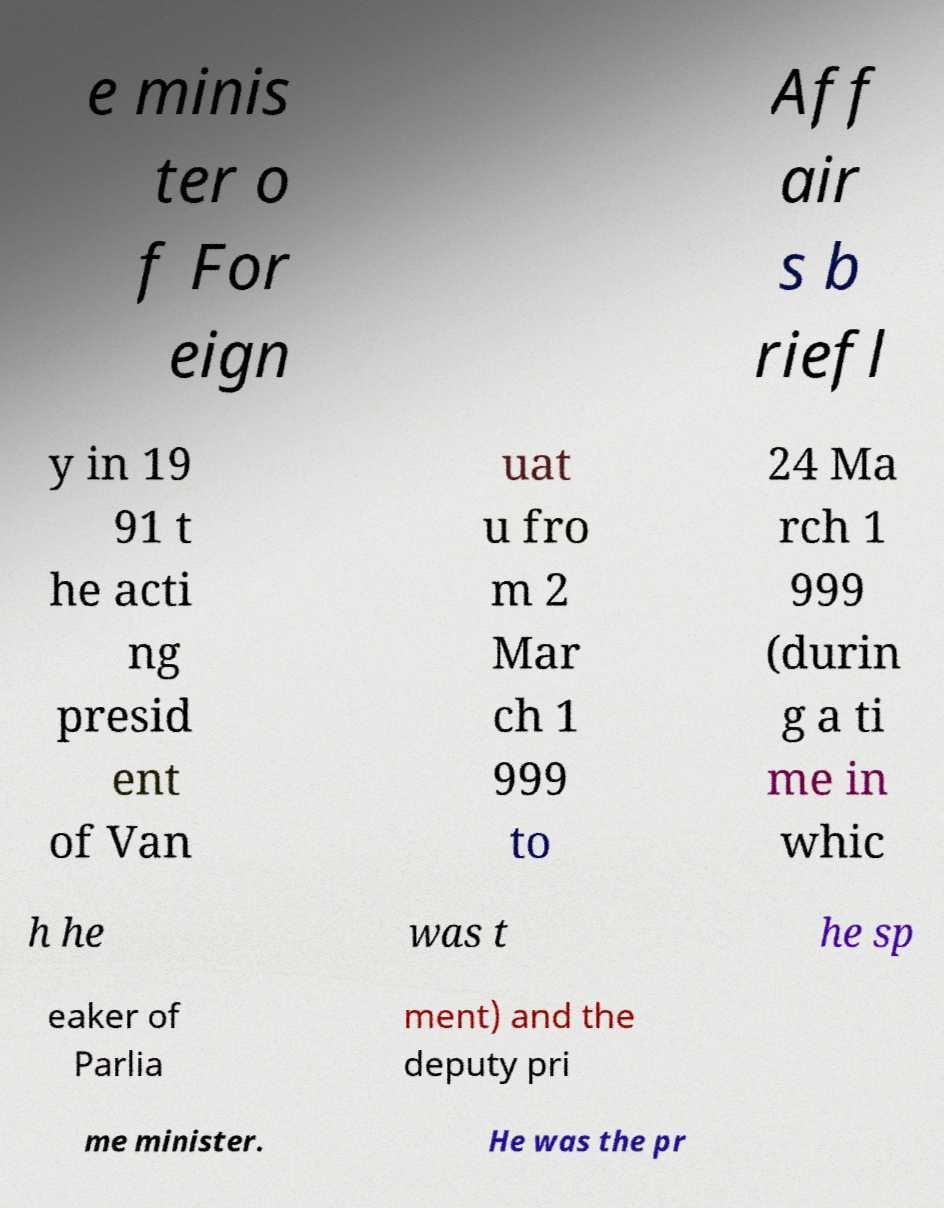I need the written content from this picture converted into text. Can you do that? e minis ter o f For eign Aff air s b riefl y in 19 91 t he acti ng presid ent of Van uat u fro m 2 Mar ch 1 999 to 24 Ma rch 1 999 (durin g a ti me in whic h he was t he sp eaker of Parlia ment) and the deputy pri me minister. He was the pr 